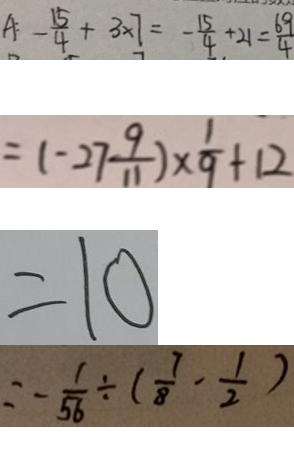Convert formula to latex. <formula><loc_0><loc_0><loc_500><loc_500>A : - \frac { 1 5 } { 4 } + 3 \times 7 = - \frac { 1 5 } { 4 } + 2 1 = \frac { 6 9 } { 4 } 
 = ( - 2 7 \frac { 9 } { 1 1 } ) \times \frac { 1 } { 9 } + 1 2 
 = 1 0 
 = - \frac { 1 } { 5 6 } \div ( \frac { 7 } { 8 } - \frac { 1 } { 2 } )</formula> 